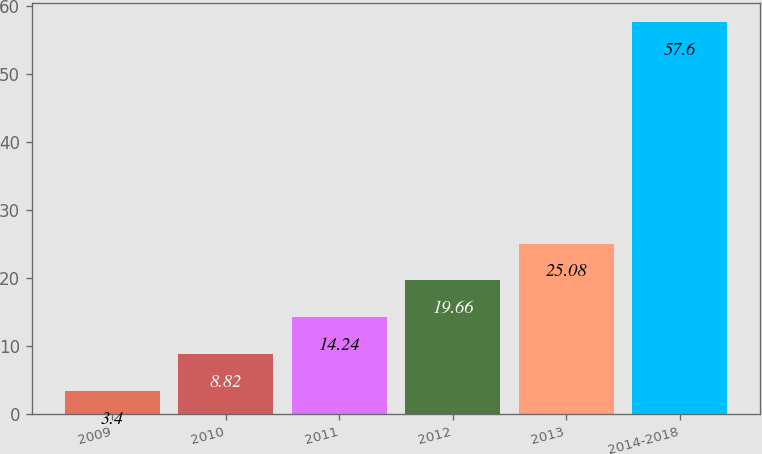<chart> <loc_0><loc_0><loc_500><loc_500><bar_chart><fcel>2009<fcel>2010<fcel>2011<fcel>2012<fcel>2013<fcel>2014-2018<nl><fcel>3.4<fcel>8.82<fcel>14.24<fcel>19.66<fcel>25.08<fcel>57.6<nl></chart> 